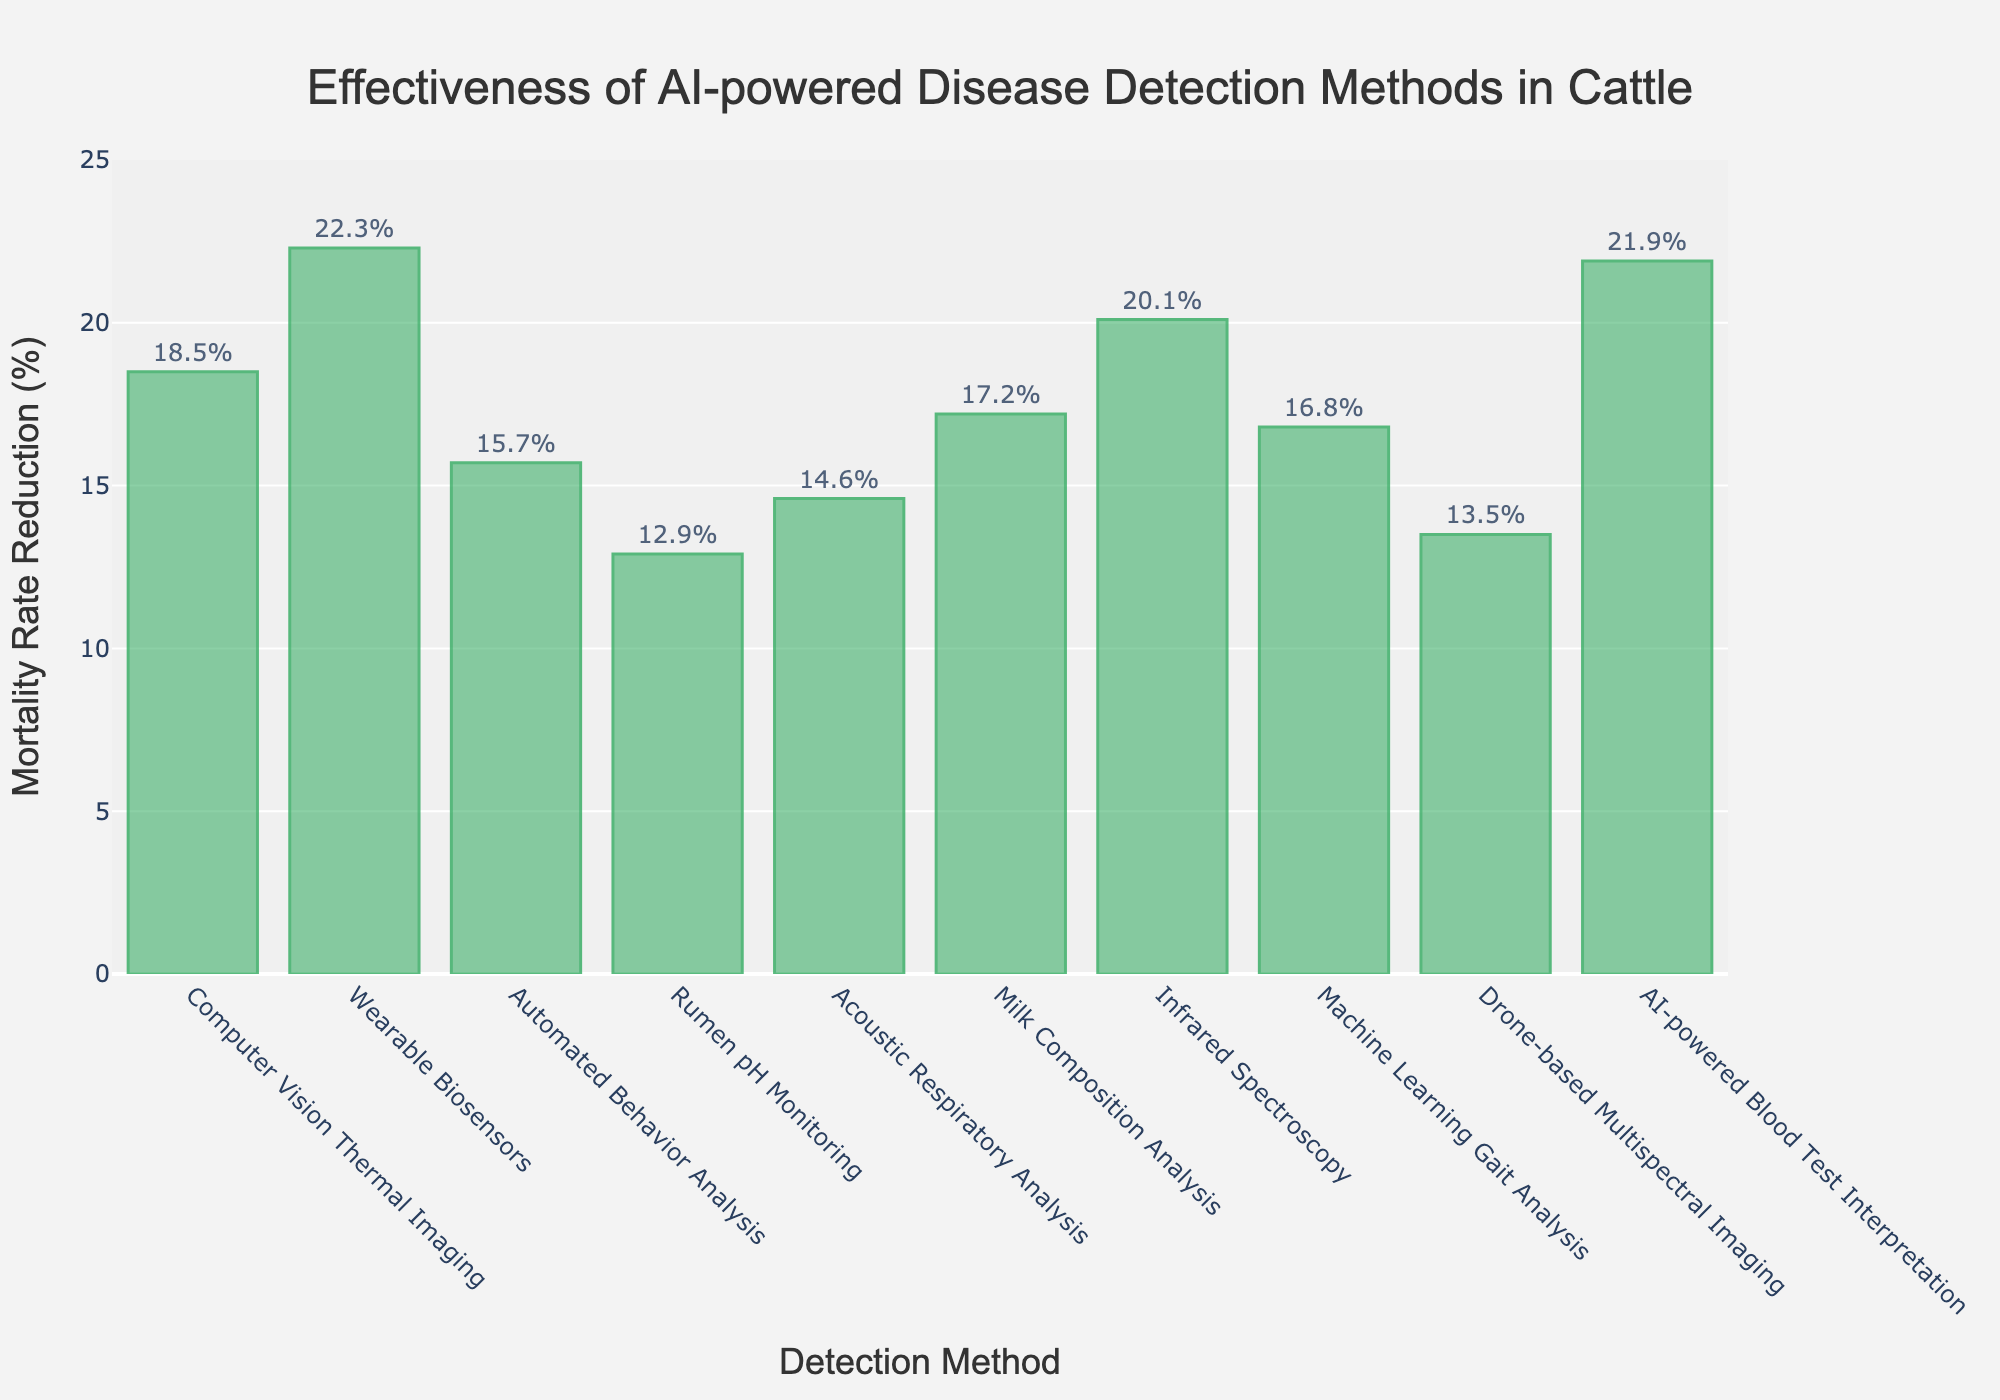What's the most effective AI-powered early disease detection method based on mortality rate reduction? The highest bar in the chart represents the Wearable Biosensors method, showing the maximum value for mortality rate reduction, which is 22.3%.
Answer: Wearable Biosensors Which AI-powered early disease detection method has the lowest mortality rate reduction? The shortest bar in the chart represents the Rumen pH Monitoring method, showing the minimum value for mortality rate reduction, which is 12.9%.
Answer: Rumen pH Monitoring How much higher is the mortality rate reduction of AI-powered Blood Test Interpretation compared to Drone-based Multispectral Imaging? The bar for AI-powered Blood Test Interpretation shows a reduction of 21.9%, and the bar for Drone-based Multispectral Imaging shows 13.5%. Subtracting these values: 21.9 - 13.5 = 8.4%.
Answer: 8.4% What is the combined mortality rate reduction for Infrared Spectroscopy and Milk Composition Analysis? The bar for Infrared Spectroscopy shows a reduction of 20.1%, and the bar for Milk Composition Analysis shows 17.2%. Adding these values: 20.1 + 17.2 = 37.3%.
Answer: 37.3% Is the mortality rate reduction for Computer Vision Thermal Imaging greater than Machine Learning Gait Analysis? The bar for Computer Vision Thermal Imaging shows a reduction of 18.5%, while the bar for Machine Learning Gait Analysis shows 16.8%. Since 18.5% is greater than 16.8%, the answer is yes.
Answer: Yes What is the average mortality rate reduction across all methods? Sum all percentages (18.5 + 22.3 + 15.7 + 12.9 + 14.6 + 17.2 + 20.1 + 16.8 + 13.5 + 21.9) gives 173.5%. Dividing by the number of methods (10) gives an average of 173.5 / 10 = 17.35%.
Answer: 17.35% Which methods have a mortality rate reduction between 15% and 20%? The bars for Computer Vision Thermal Imaging (18.5%), Automated Behavior Analysis (15.7%), Acoustic Respiratory Analysis (14.6%), Milk Composition Analysis (17.2%), Infrared Spectroscopy (20.1%), and Machine Learning Gait Analysis (16.8%) meet the criteria.
Answer: Computer Vision Thermal Imaging, Automated Behavior Analysis, Milk Composition Analysis, Machine Learning Gait Analysis Compare the total mortality rate reduction of top 3 and bottom 3 methods. Top three methods: Wearable Biosensors (22.3%), AI-powered Blood Test Interpretation (21.9%), Infrared Spectroscopy (20.1%). Bottom three methods: Rumen pH Monitoring (12.9%), Drone-based Multispectral Imaging (13.5%), Acoustic Respiratory Analysis (14.6%). Total for top three = 22.3 + 21.9 + 20.1 = 64.3%. Total for bottom three = 12.9 + 13.5 + 14.6 = 41%.
Answer: Top 3: 64.3%, Bottom 3: 41% 